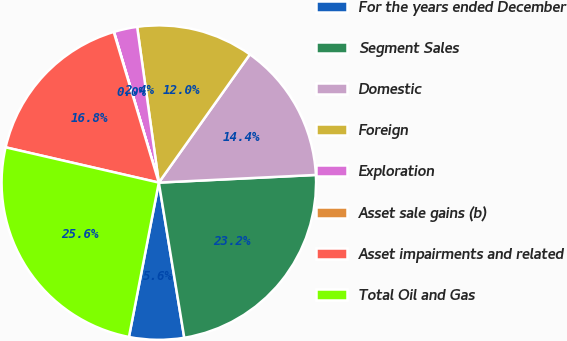Convert chart to OTSL. <chart><loc_0><loc_0><loc_500><loc_500><pie_chart><fcel>For the years ended December<fcel>Segment Sales<fcel>Domestic<fcel>Foreign<fcel>Exploration<fcel>Asset sale gains (b)<fcel>Asset impairments and related<fcel>Total Oil and Gas<nl><fcel>5.63%<fcel>23.19%<fcel>14.4%<fcel>12.03%<fcel>2.4%<fcel>0.03%<fcel>16.77%<fcel>25.56%<nl></chart> 